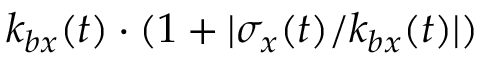<formula> <loc_0><loc_0><loc_500><loc_500>k _ { b x } ( t ) \cdot ( 1 + | \sigma _ { x } ( t ) / k _ { b x } ( t ) | )</formula> 